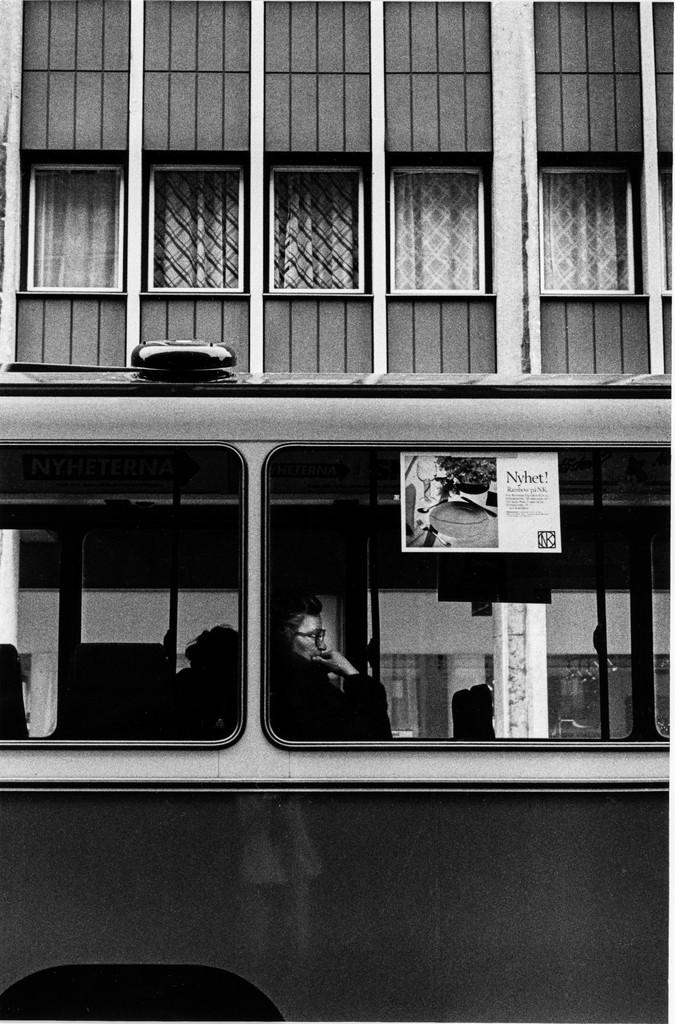What is the color scheme of the image? The image is black and white. What can be seen inside the vehicle in the image? There is a person in a vehicle in the image. What is displayed on the poster in the image? There is a poster with images and text in the image. What features can be observed on the wall in the image? There is a wall with windows and curtains in the image. What type of pie is being served in the image? There is no pie present in the image. What is the make and model of the engine in the vehicle? There is no engine visible in the image, as it is focused on the person inside the vehicle. 